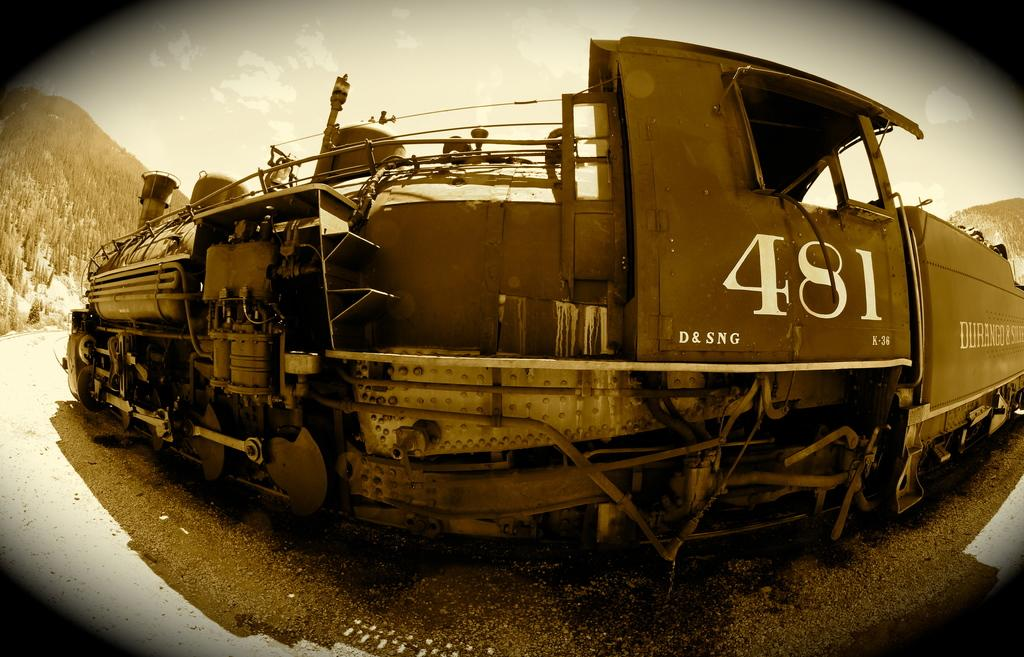<image>
Create a compact narrative representing the image presented. A large piece of machinery has the numbers 481 on the side. 